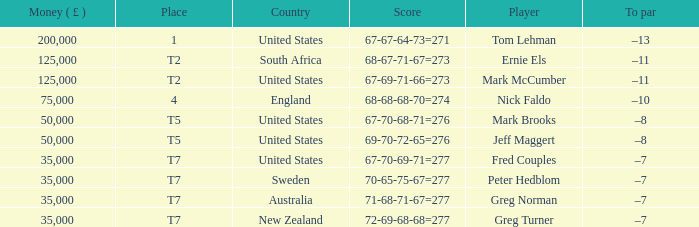What is To par, when Country is "United States", when Money ( £ ) is greater than 125,000, and when Score is "67-70-68-71=276"? None. 